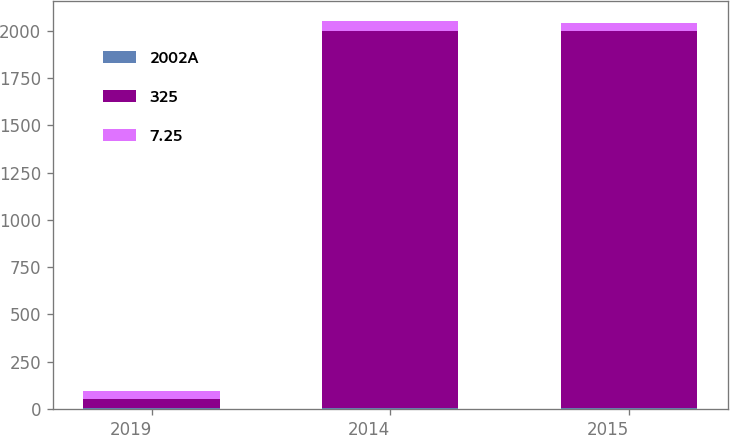Convert chart to OTSL. <chart><loc_0><loc_0><loc_500><loc_500><stacked_bar_chart><ecel><fcel>2019<fcel>2014<fcel>2015<nl><fcel>2002A<fcel>5.22<fcel>3.45<fcel>3.45<nl><fcel>325<fcel>44.5<fcel>1994<fcel>1995<nl><fcel>7.25<fcel>45<fcel>55<fcel>44<nl></chart> 